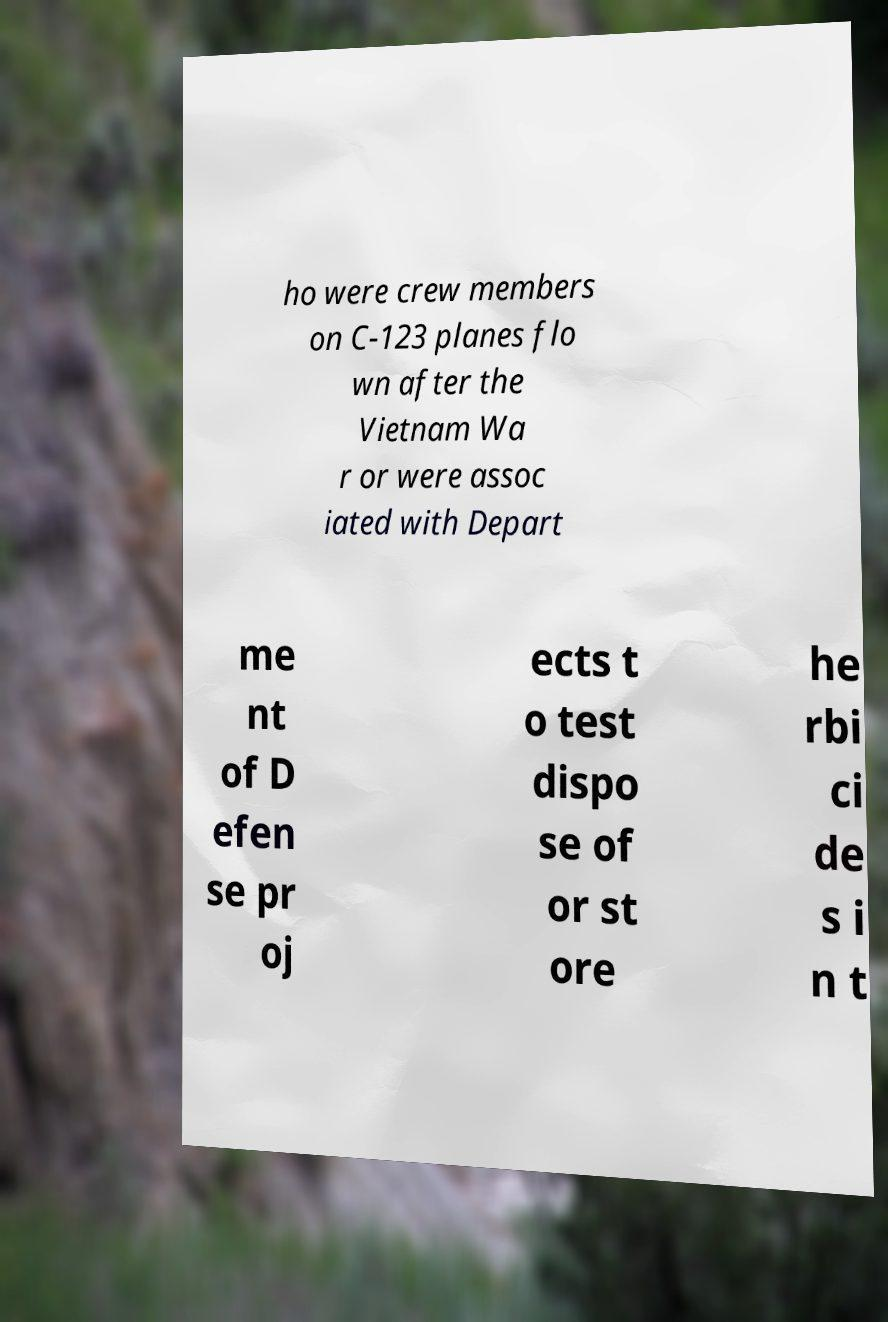I need the written content from this picture converted into text. Can you do that? ho were crew members on C-123 planes flo wn after the Vietnam Wa r or were assoc iated with Depart me nt of D efen se pr oj ects t o test dispo se of or st ore he rbi ci de s i n t 